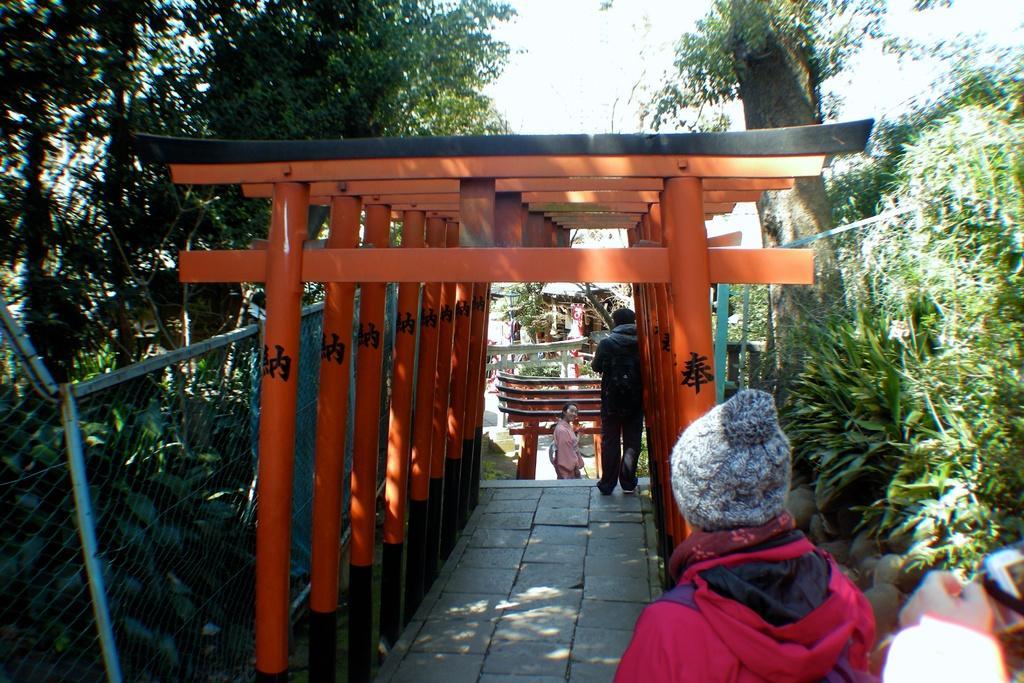In one or two sentences, can you explain what this image depicts? In the center of the image we can see torii gates and there are people. On the left there is a mesh. In the background there are trees and sky. 